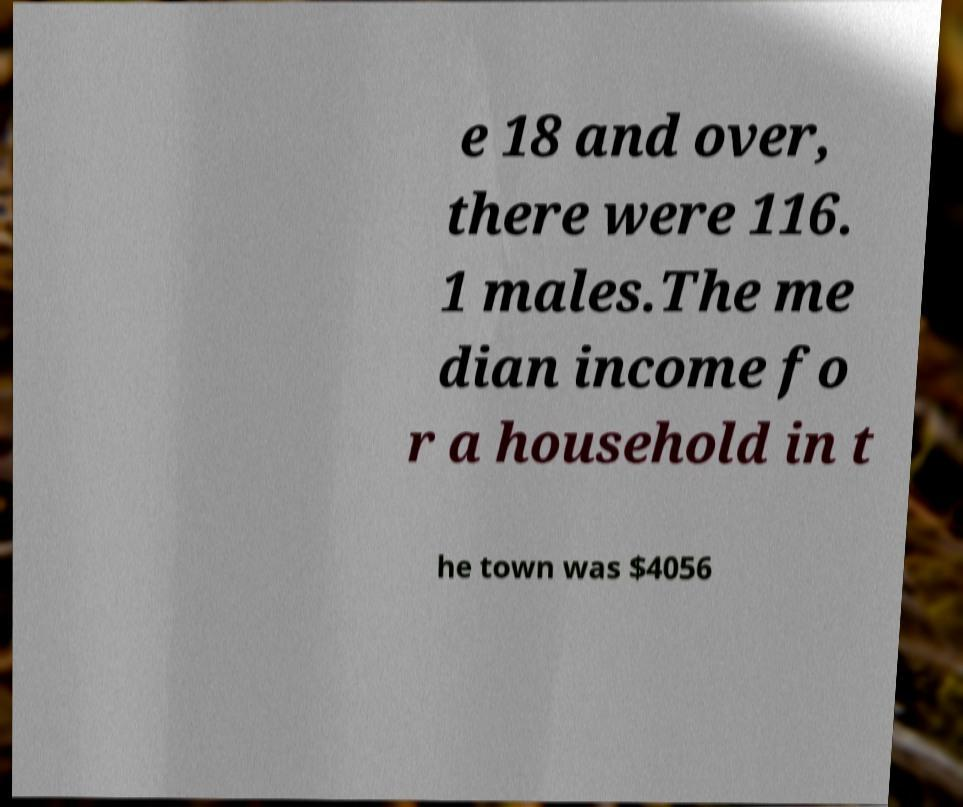Could you assist in decoding the text presented in this image and type it out clearly? e 18 and over, there were 116. 1 males.The me dian income fo r a household in t he town was $4056 